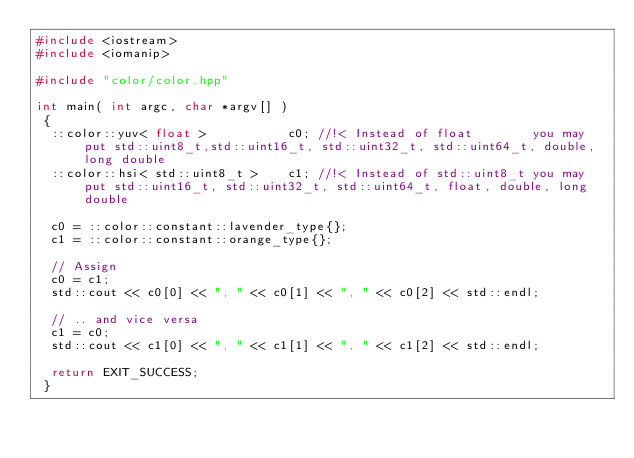<code> <loc_0><loc_0><loc_500><loc_500><_C++_>#include <iostream>
#include <iomanip>

#include "color/color.hpp"

int main( int argc, char *argv[] )
 {
  ::color::yuv< float >           c0; //!< Instead of float        you may put std::uint8_t,std::uint16_t, std::uint32_t, std::uint64_t, double, long double
  ::color::hsi< std::uint8_t >    c1; //!< Instead of std::uint8_t you may put std::uint16_t, std::uint32_t, std::uint64_t, float, double, long double

  c0 = ::color::constant::lavender_type{};
  c1 = ::color::constant::orange_type{};

  // Assign
  c0 = c1;
  std::cout << c0[0] << ", " << c0[1] << ", " << c0[2] << std::endl;

  // .. and vice versa
  c1 = c0;
  std::cout << c1[0] << ", " << c1[1] << ", " << c1[2] << std::endl;

  return EXIT_SUCCESS;
 }
</code> 